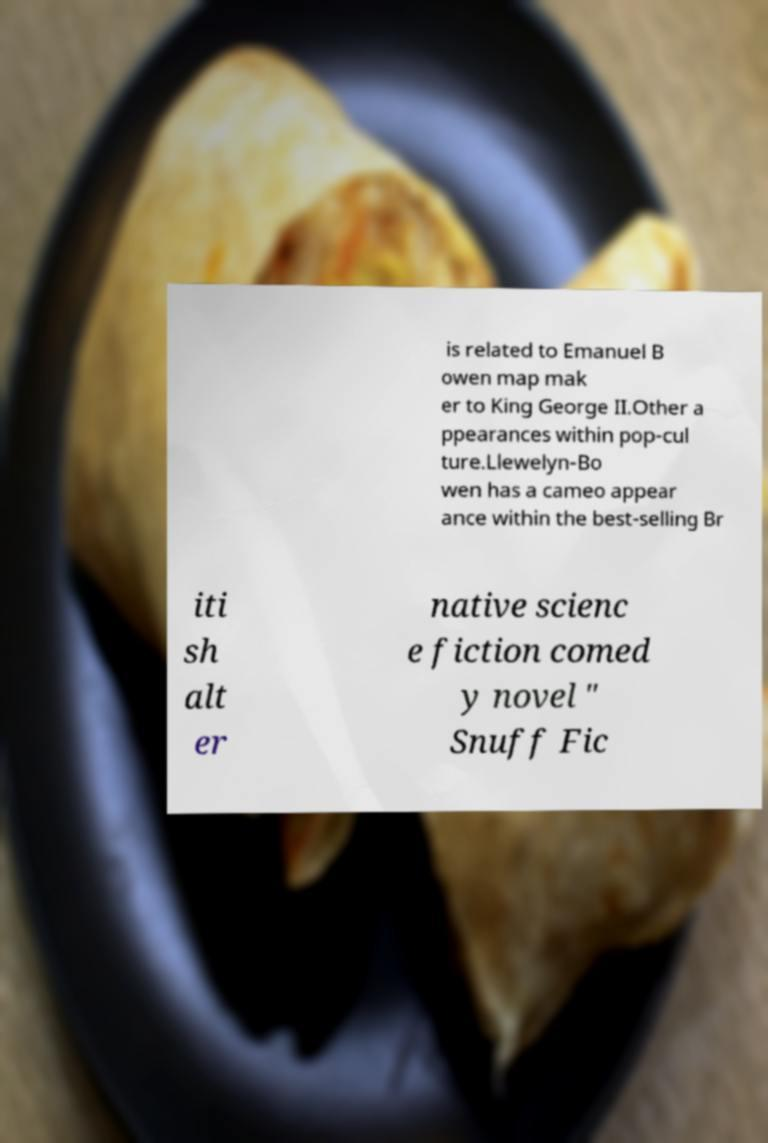Can you accurately transcribe the text from the provided image for me? is related to Emanuel B owen map mak er to King George II.Other a ppearances within pop-cul ture.Llewelyn-Bo wen has a cameo appear ance within the best-selling Br iti sh alt er native scienc e fiction comed y novel " Snuff Fic 